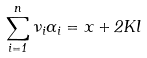Convert formula to latex. <formula><loc_0><loc_0><loc_500><loc_500>\sum _ { i = 1 } ^ { n } \nu _ { i } \alpha _ { i } = x + 2 K l</formula> 